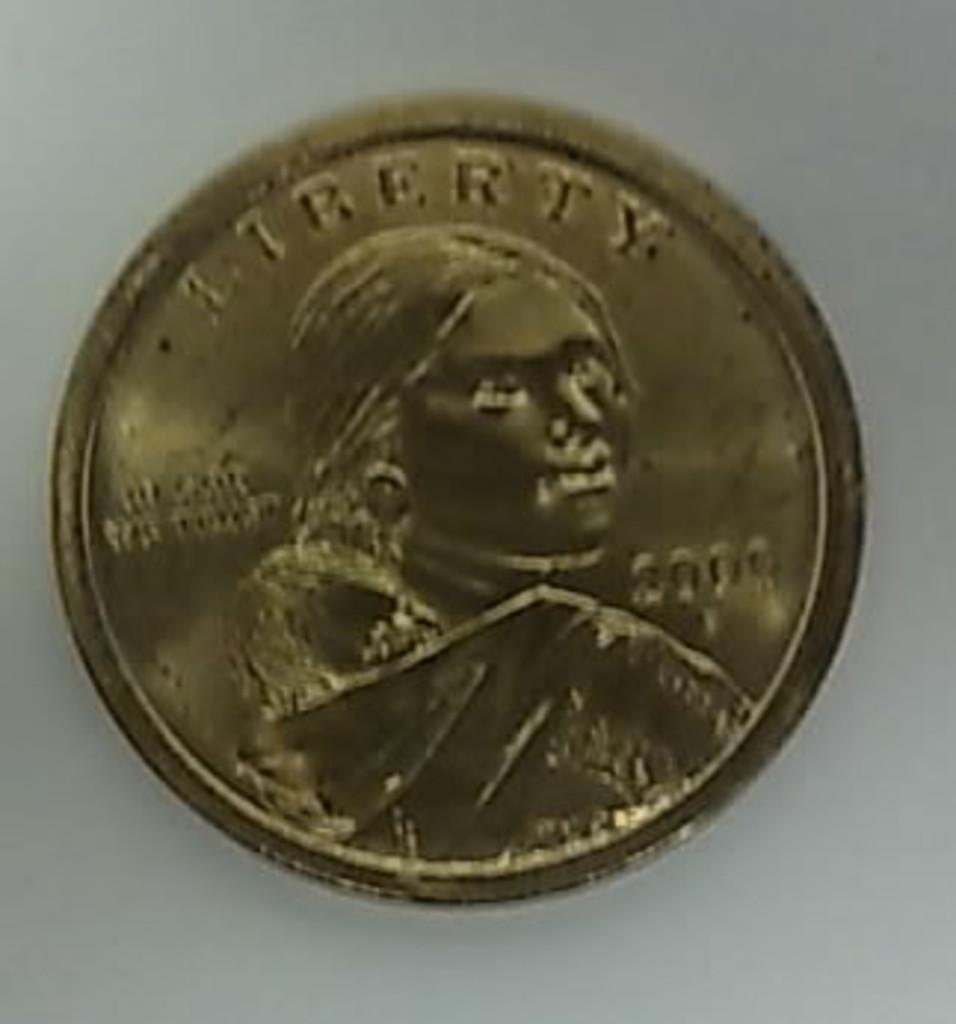<image>
Render a clear and concise summary of the photo. A gold Liberty coin is laying on a grey background. 